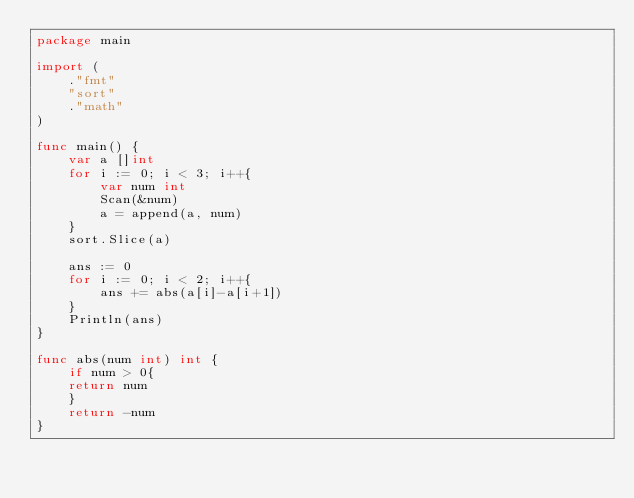Convert code to text. <code><loc_0><loc_0><loc_500><loc_500><_Go_>package main

import (
	."fmt"
	"sort"
	."math"
)

func main() {
	var a []int
	for i := 0; i < 3; i++{
		var num int
		Scan(&num)
		a = append(a, num)
	}
	sort.Slice(a)

	ans := 0
	for i := 0; i < 2; i++{
		ans += abs(a[i]-a[i+1])
	}
	Println(ans)
}

func abs(num int) int {
	if num > 0{
	return num
	}
	return -num
}
</code> 